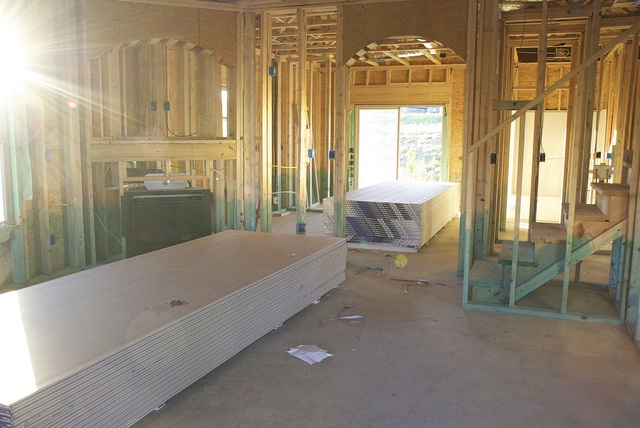Describe the objects in this image and their specific colors. I can see bed in ivory, gray, lightgray, darkgray, and tan tones and tv in ivory, gray, and darkgreen tones in this image. 